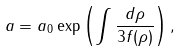<formula> <loc_0><loc_0><loc_500><loc_500>a = a _ { 0 } \exp \left ( \int \frac { d \rho } { 3 f ( \rho ) } \right ) ,</formula> 